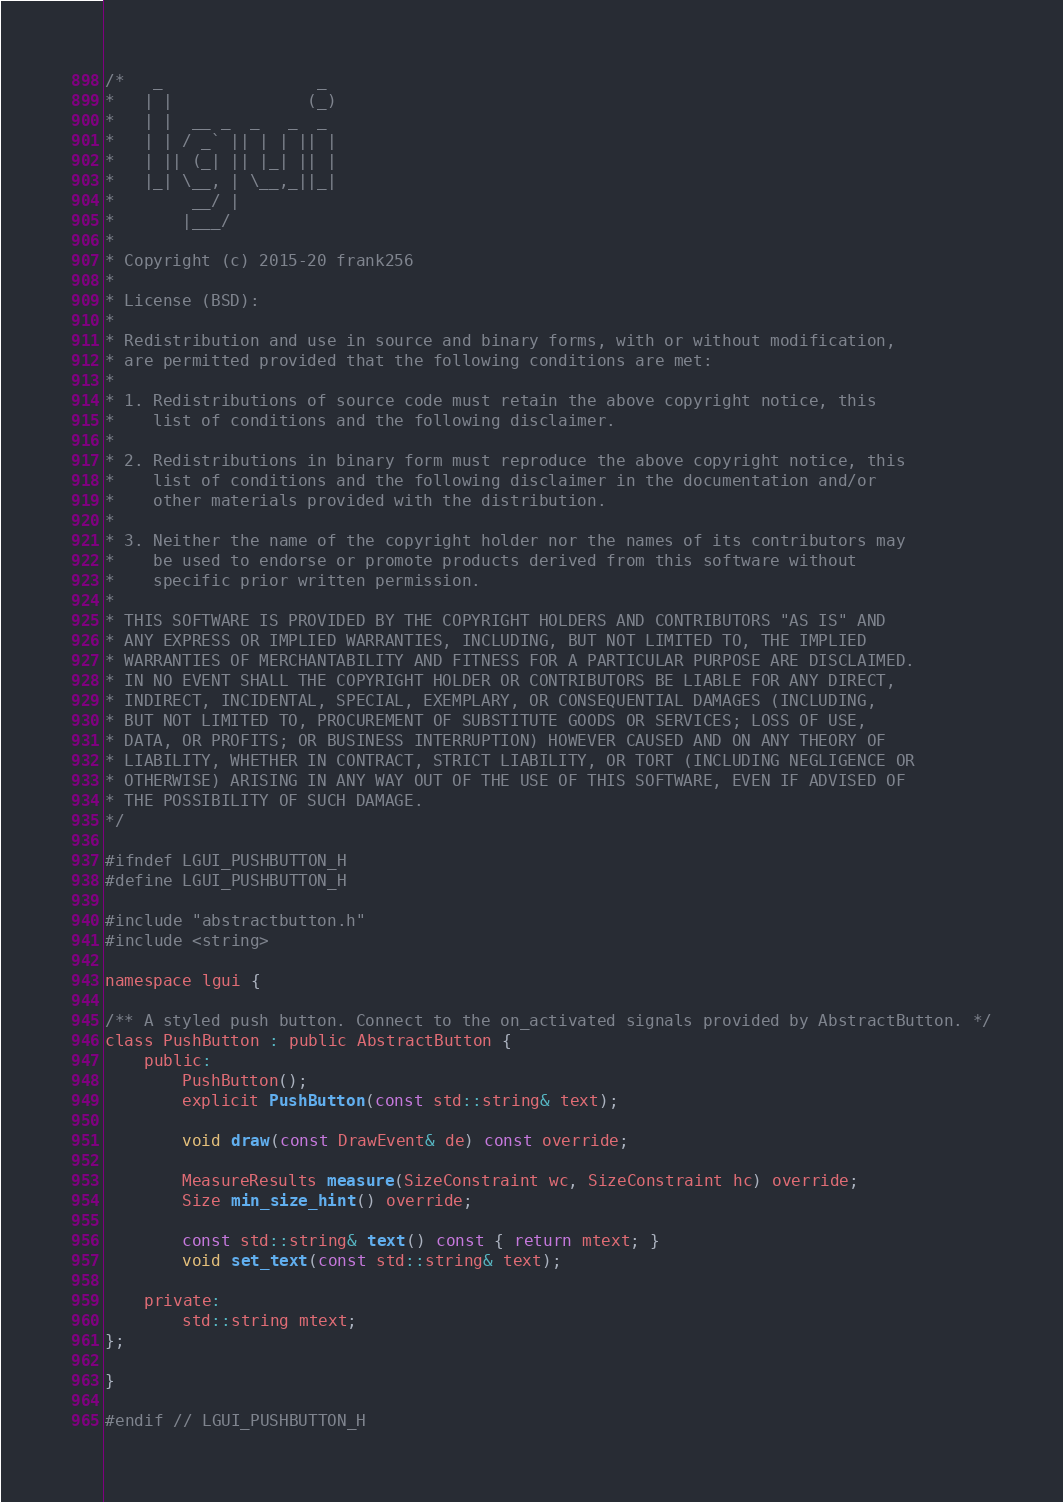Convert code to text. <code><loc_0><loc_0><loc_500><loc_500><_C_>/*   _                _
*   | |              (_)
*   | |  __ _  _   _  _
*   | | / _` || | | || |
*   | || (_| || |_| || |
*   |_| \__, | \__,_||_|
*        __/ |
*       |___/
*
* Copyright (c) 2015-20 frank256
*
* License (BSD):
*
* Redistribution and use in source and binary forms, with or without modification,
* are permitted provided that the following conditions are met:
*
* 1. Redistributions of source code must retain the above copyright notice, this
*    list of conditions and the following disclaimer.
*
* 2. Redistributions in binary form must reproduce the above copyright notice, this
*    list of conditions and the following disclaimer in the documentation and/or
*    other materials provided with the distribution.
*
* 3. Neither the name of the copyright holder nor the names of its contributors may
*    be used to endorse or promote products derived from this software without
*    specific prior written permission.
*
* THIS SOFTWARE IS PROVIDED BY THE COPYRIGHT HOLDERS AND CONTRIBUTORS "AS IS" AND
* ANY EXPRESS OR IMPLIED WARRANTIES, INCLUDING, BUT NOT LIMITED TO, THE IMPLIED
* WARRANTIES OF MERCHANTABILITY AND FITNESS FOR A PARTICULAR PURPOSE ARE DISCLAIMED.
* IN NO EVENT SHALL THE COPYRIGHT HOLDER OR CONTRIBUTORS BE LIABLE FOR ANY DIRECT,
* INDIRECT, INCIDENTAL, SPECIAL, EXEMPLARY, OR CONSEQUENTIAL DAMAGES (INCLUDING,
* BUT NOT LIMITED TO, PROCUREMENT OF SUBSTITUTE GOODS OR SERVICES; LOSS OF USE,
* DATA, OR PROFITS; OR BUSINESS INTERRUPTION) HOWEVER CAUSED AND ON ANY THEORY OF
* LIABILITY, WHETHER IN CONTRACT, STRICT LIABILITY, OR TORT (INCLUDING NEGLIGENCE OR
* OTHERWISE) ARISING IN ANY WAY OUT OF THE USE OF THIS SOFTWARE, EVEN IF ADVISED OF
* THE POSSIBILITY OF SUCH DAMAGE.
*/

#ifndef LGUI_PUSHBUTTON_H
#define LGUI_PUSHBUTTON_H

#include "abstractbutton.h"
#include <string>

namespace lgui {

/** A styled push button. Connect to the on_activated signals provided by AbstractButton. */
class PushButton : public AbstractButton {
    public:
        PushButton();
        explicit PushButton(const std::string& text);

        void draw(const DrawEvent& de) const override;

        MeasureResults measure(SizeConstraint wc, SizeConstraint hc) override;
        Size min_size_hint() override;

        const std::string& text() const { return mtext; }
        void set_text(const std::string& text);

    private:
        std::string mtext;
};

}

#endif // LGUI_PUSHBUTTON_H
</code> 